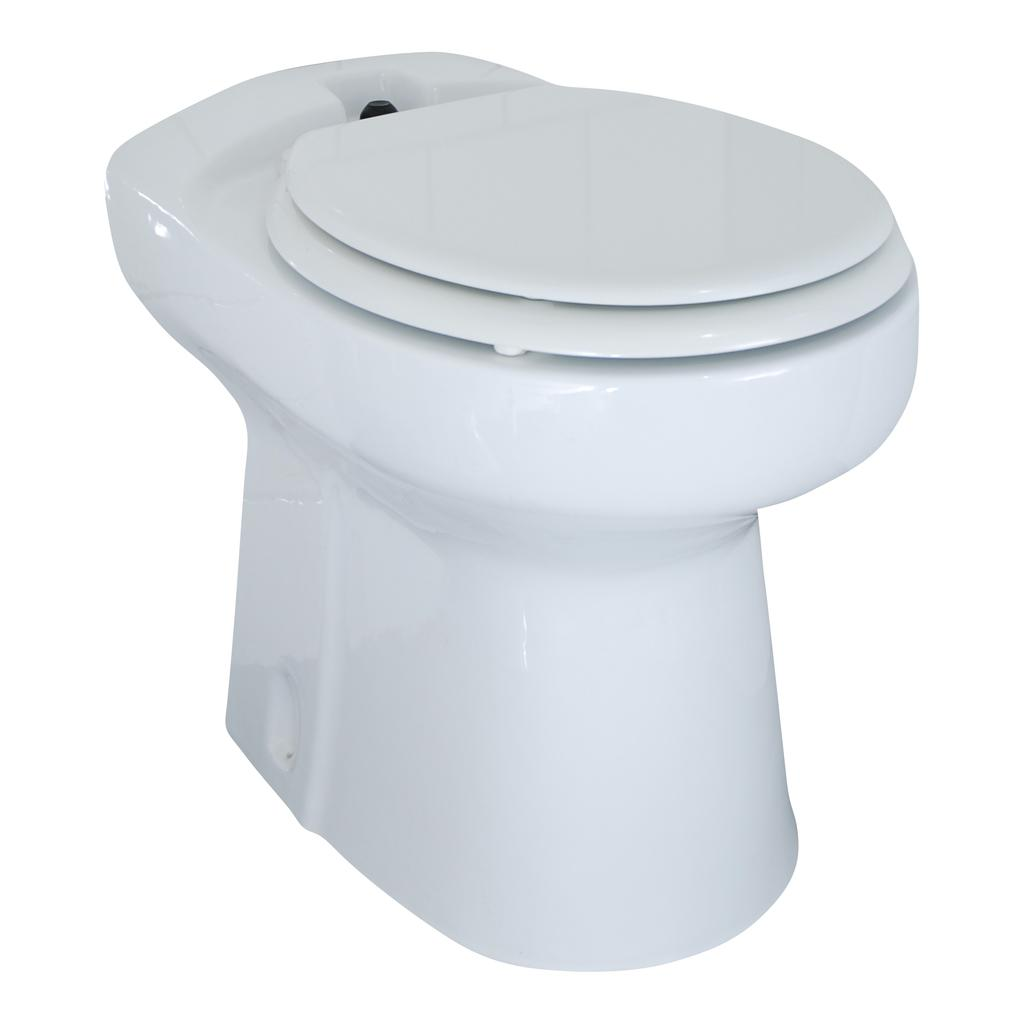What type of toilet is visible in the image? There is a western toilet in the image. What color is the background of the image? The background of the image is white. What type of hammer is hanging on the wall in the image? There is no hammer present in the image. Are there any fairies visible in the image? There are no fairies present in the image. 